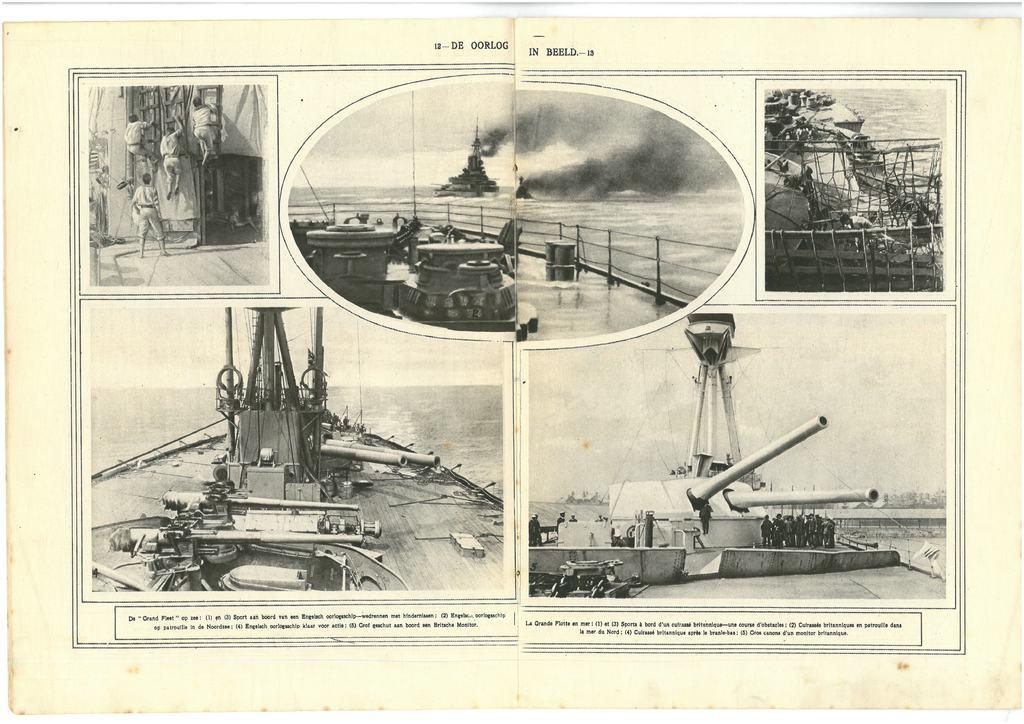What is the medium of the image? The image is a paper. What type of vehicles are depicted in the image? There are ships in the image. What is the setting of the image? There is water in the image. Are there any human figures in the image? Yes, there are people in the image. What objects are used for climbing in the image? There are ladders in the image. What type of weapon is present in the image? There is a weapon in the image. Is there any text written on the paper? Yes, there is text written on the paper. What type of collar can be seen on the food in the image? There is no food or collar present in the image. How deep is the quicksand in the image? There is no quicksand present in the image. 